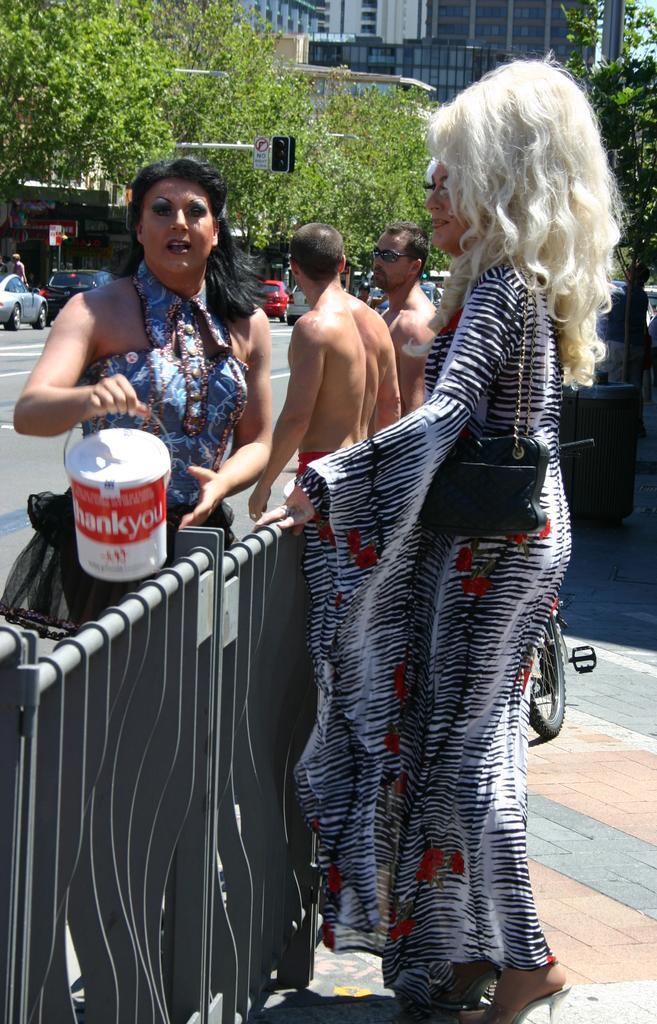How would you summarize this image in a sentence or two? In this image there are people. At the bottom there is a fence. In the background there are cars, trees, buildings and a traffic light. 